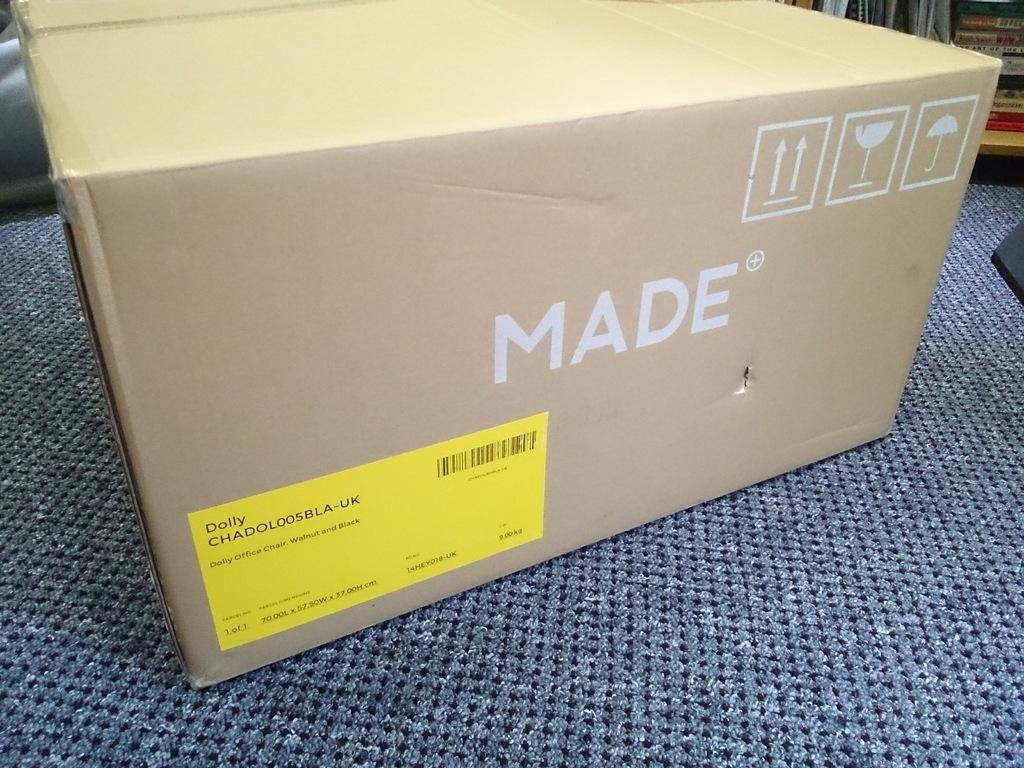<image>
Share a concise interpretation of the image provided. A box with the word made on it sitting on the floor. 